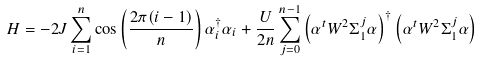Convert formula to latex. <formula><loc_0><loc_0><loc_500><loc_500>H = - 2 J \sum _ { i = 1 } ^ { n } \cos \left ( \frac { 2 \pi ( i - 1 ) } { n } \right ) \alpha _ { i } ^ { \dagger } \alpha _ { i } + \frac { U } { 2 n } \sum _ { j = 0 } ^ { n - 1 } \left ( { \alpha } ^ { t } W ^ { 2 } \Sigma _ { 1 } ^ { j } { \alpha } \right ) ^ { \dagger } \left ( { \alpha } ^ { t } W ^ { 2 } \Sigma _ { 1 } ^ { j } { \alpha } \right )</formula> 